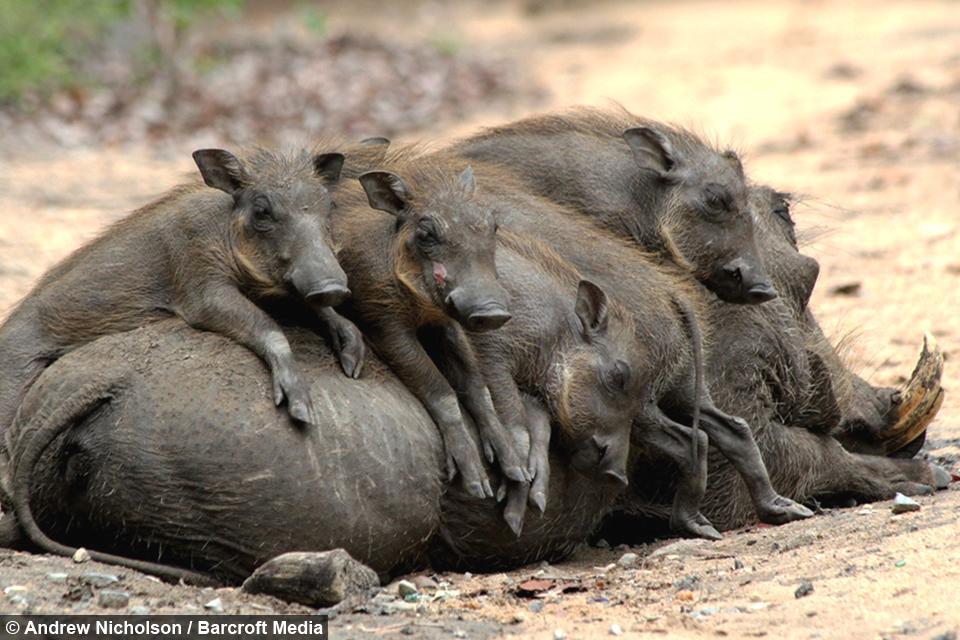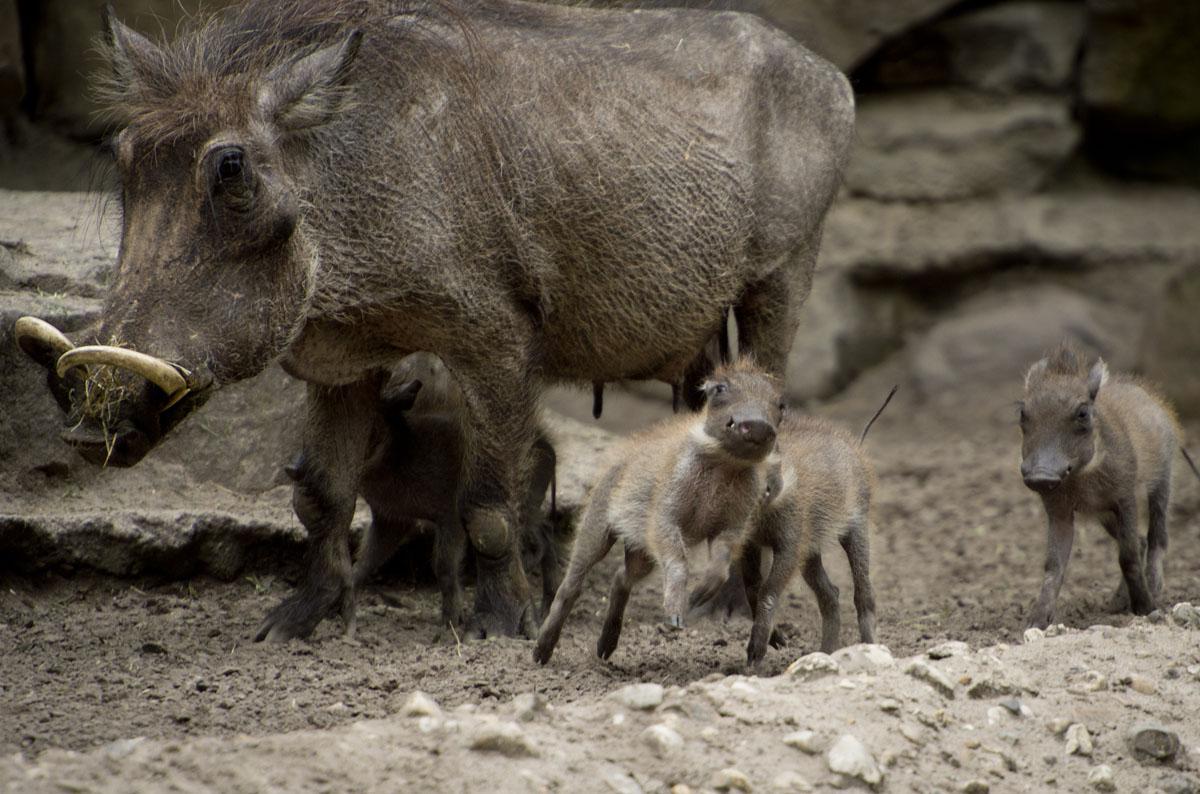The first image is the image on the left, the second image is the image on the right. Evaluate the accuracy of this statement regarding the images: "An image contains a cheetah attacking a wart hog.". Is it true? Answer yes or no. No. The first image is the image on the left, the second image is the image on the right. Examine the images to the left and right. Is the description "An image includes multiple piglets with an adult warthog standing in profile facing leftward." accurate? Answer yes or no. Yes. 